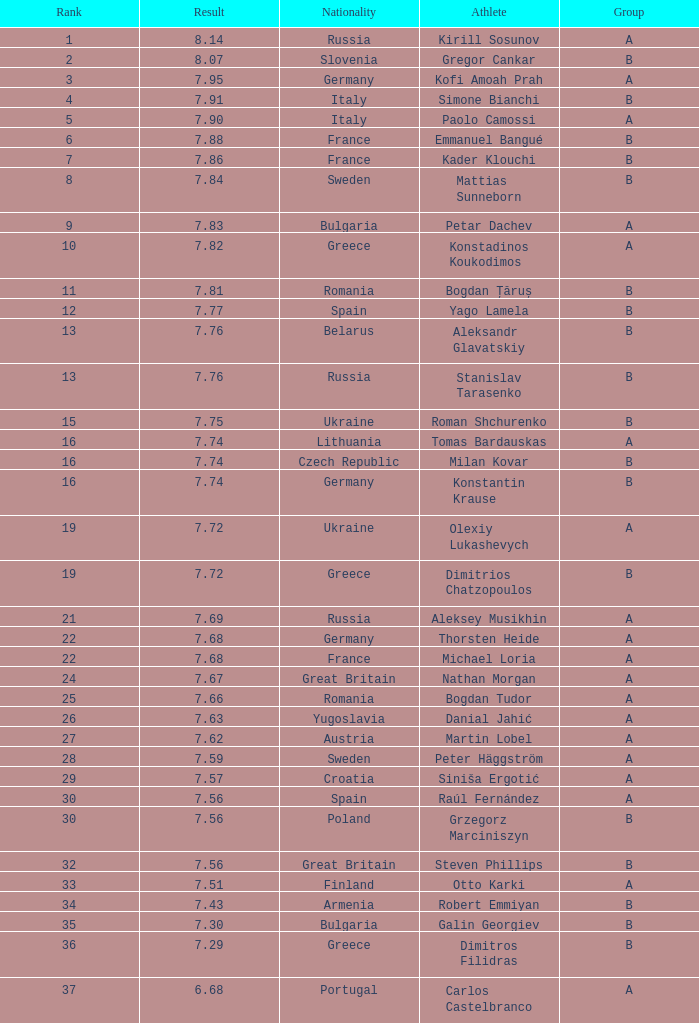Which sportsman's position is higher than 15 when the outcome is below Steven Phillips. 